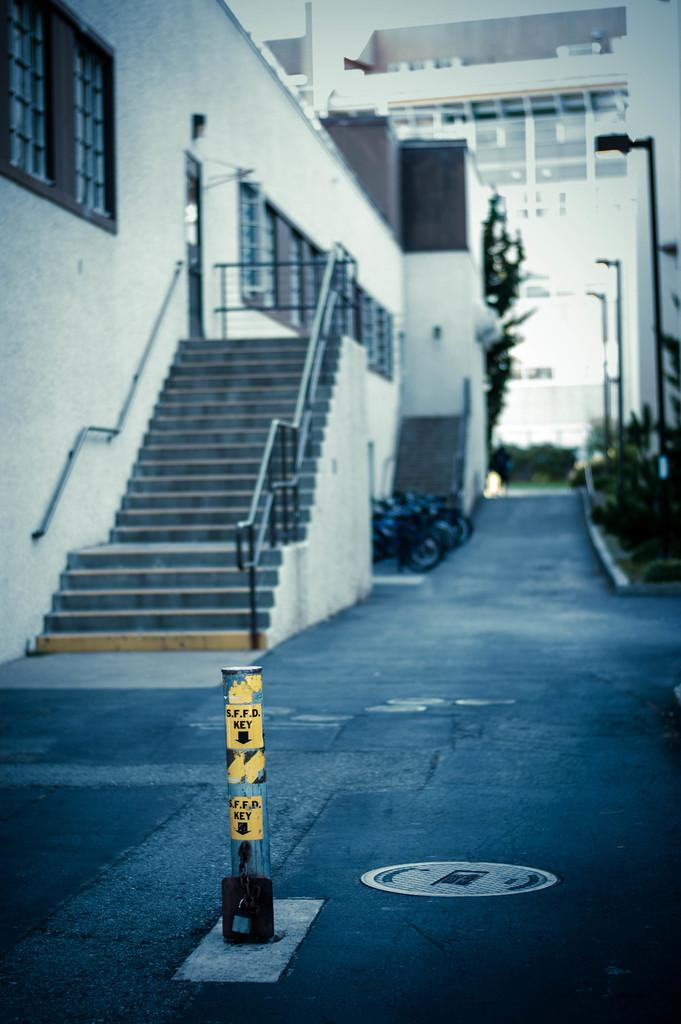What type of structure is present in the image? There is a building in the image. Can you describe any specific features of the building? The building has windows. What else can be seen in the image besides the building? There is a rod, a staircase, bikes, plants, poles, and a road visible in the image. Where is the faucet located in the image? There is no faucet present in the image. How does the image capture the attention of the viewer? The question about capturing the attention of the viewer is subjective and cannot be definitively answered based on the provided facts. 